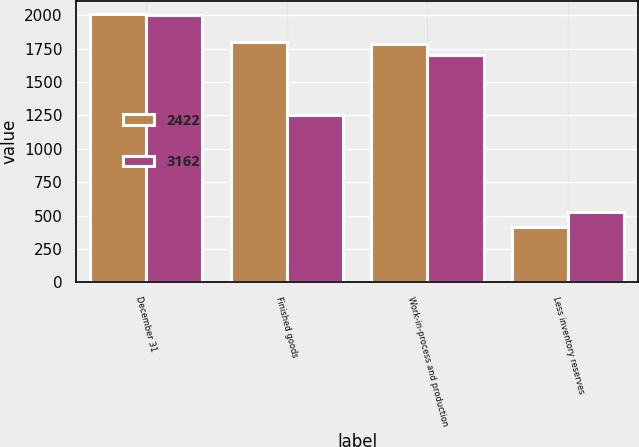Convert chart. <chart><loc_0><loc_0><loc_500><loc_500><stacked_bar_chart><ecel><fcel>December 31<fcel>Finished goods<fcel>Work-in-process and production<fcel>Less inventory reserves<nl><fcel>2422<fcel>2006<fcel>1796<fcel>1782<fcel>416<nl><fcel>3162<fcel>2005<fcel>1252<fcel>1699<fcel>529<nl></chart> 